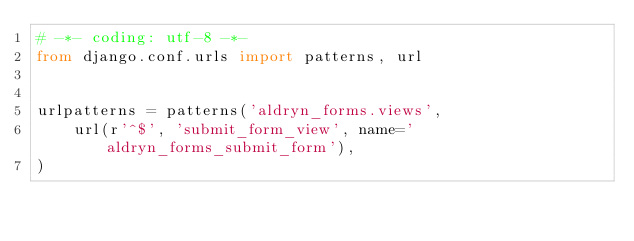<code> <loc_0><loc_0><loc_500><loc_500><_Python_># -*- coding: utf-8 -*-
from django.conf.urls import patterns, url


urlpatterns = patterns('aldryn_forms.views',
    url(r'^$', 'submit_form_view', name='aldryn_forms_submit_form'),
)
</code> 